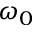<formula> <loc_0><loc_0><loc_500><loc_500>\omega _ { 0 }</formula> 